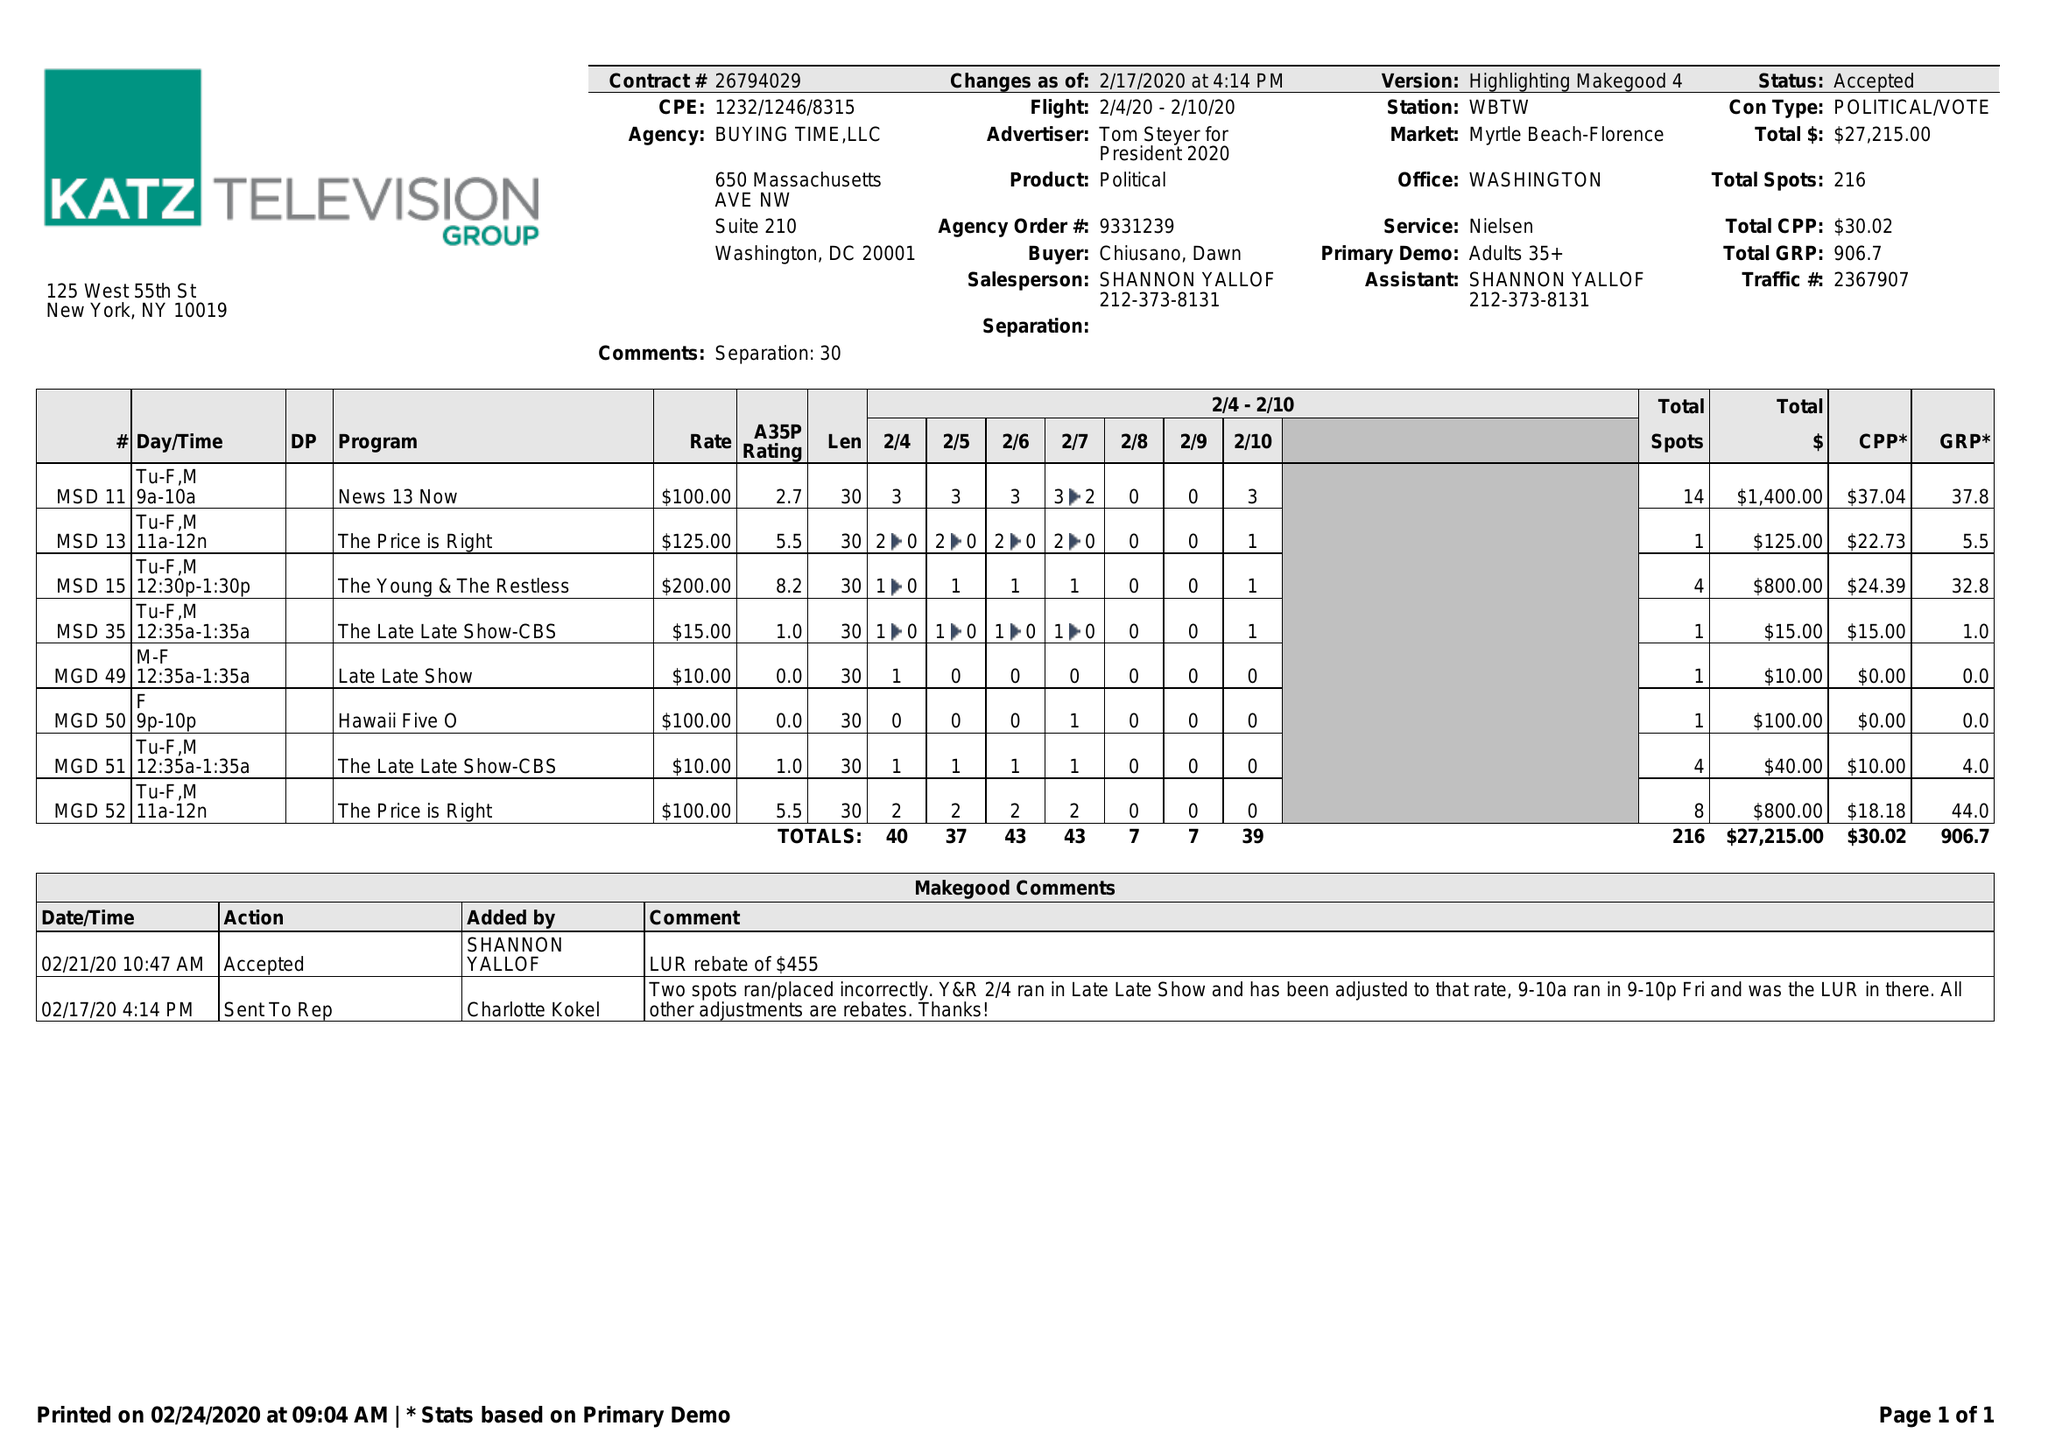What is the value for the advertiser?
Answer the question using a single word or phrase. TOM STEYER FOR PRESIDENT 2020 